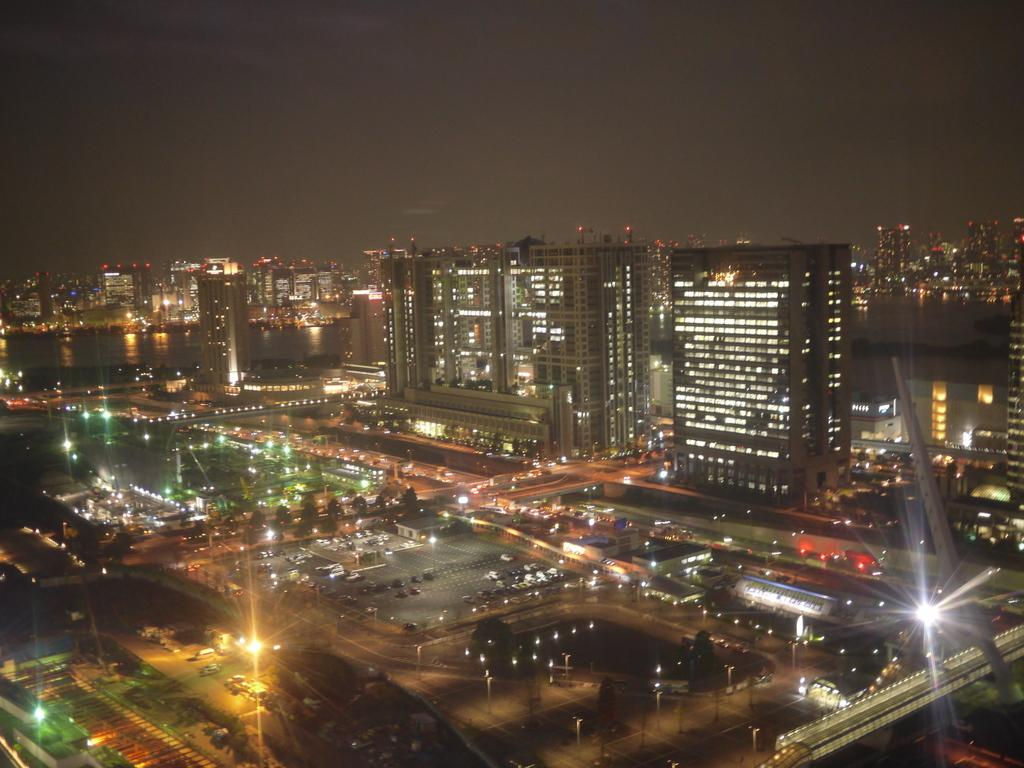What type of structures can be seen in the image? There are buildings in the image. What can be found between the buildings? There are roads in the image. What is moving along the roads? There are vehicles in the image. What illuminates the scene in the image? There are lights in the image. What type of vegetation is present in the image? There are trees in the image. What is visible in the background of the image? The sky is visible in the background of the image. Where is the doctor located in the image? There is no doctor present in the image. What type of park can be seen in the image? There is no park present in the image. 